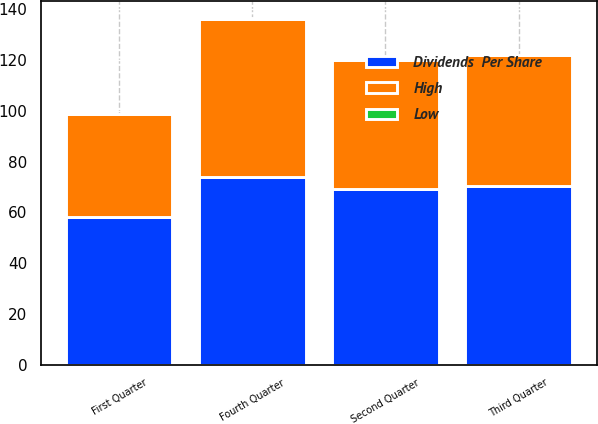Convert chart. <chart><loc_0><loc_0><loc_500><loc_500><stacked_bar_chart><ecel><fcel>First Quarter<fcel>Second Quarter<fcel>Third Quarter<fcel>Fourth Quarter<nl><fcel>Dividends  Per Share<fcel>58.24<fcel>69.07<fcel>70.35<fcel>74.09<nl><fcel>High<fcel>40.33<fcel>50.86<fcel>51.49<fcel>62.25<nl><fcel>Low<fcel>0.18<fcel>0.18<fcel>0.18<fcel>0.18<nl></chart> 